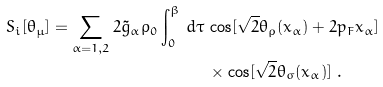<formula> <loc_0><loc_0><loc_500><loc_500>S _ { i } [ \theta _ { \mu } ] = \sum _ { \alpha = 1 , 2 } 2 \tilde { g } _ { \alpha } \rho _ { 0 } \int _ { 0 } ^ { \beta } \, d \tau \, & \cos [ \sqrt { 2 } \theta _ { \rho } ( x _ { \alpha } ) + 2 p _ { F } x _ { \alpha } ] \\ & \times \cos [ \sqrt { 2 } \theta _ { \sigma } ( x _ { \alpha } ) ] \ .</formula> 